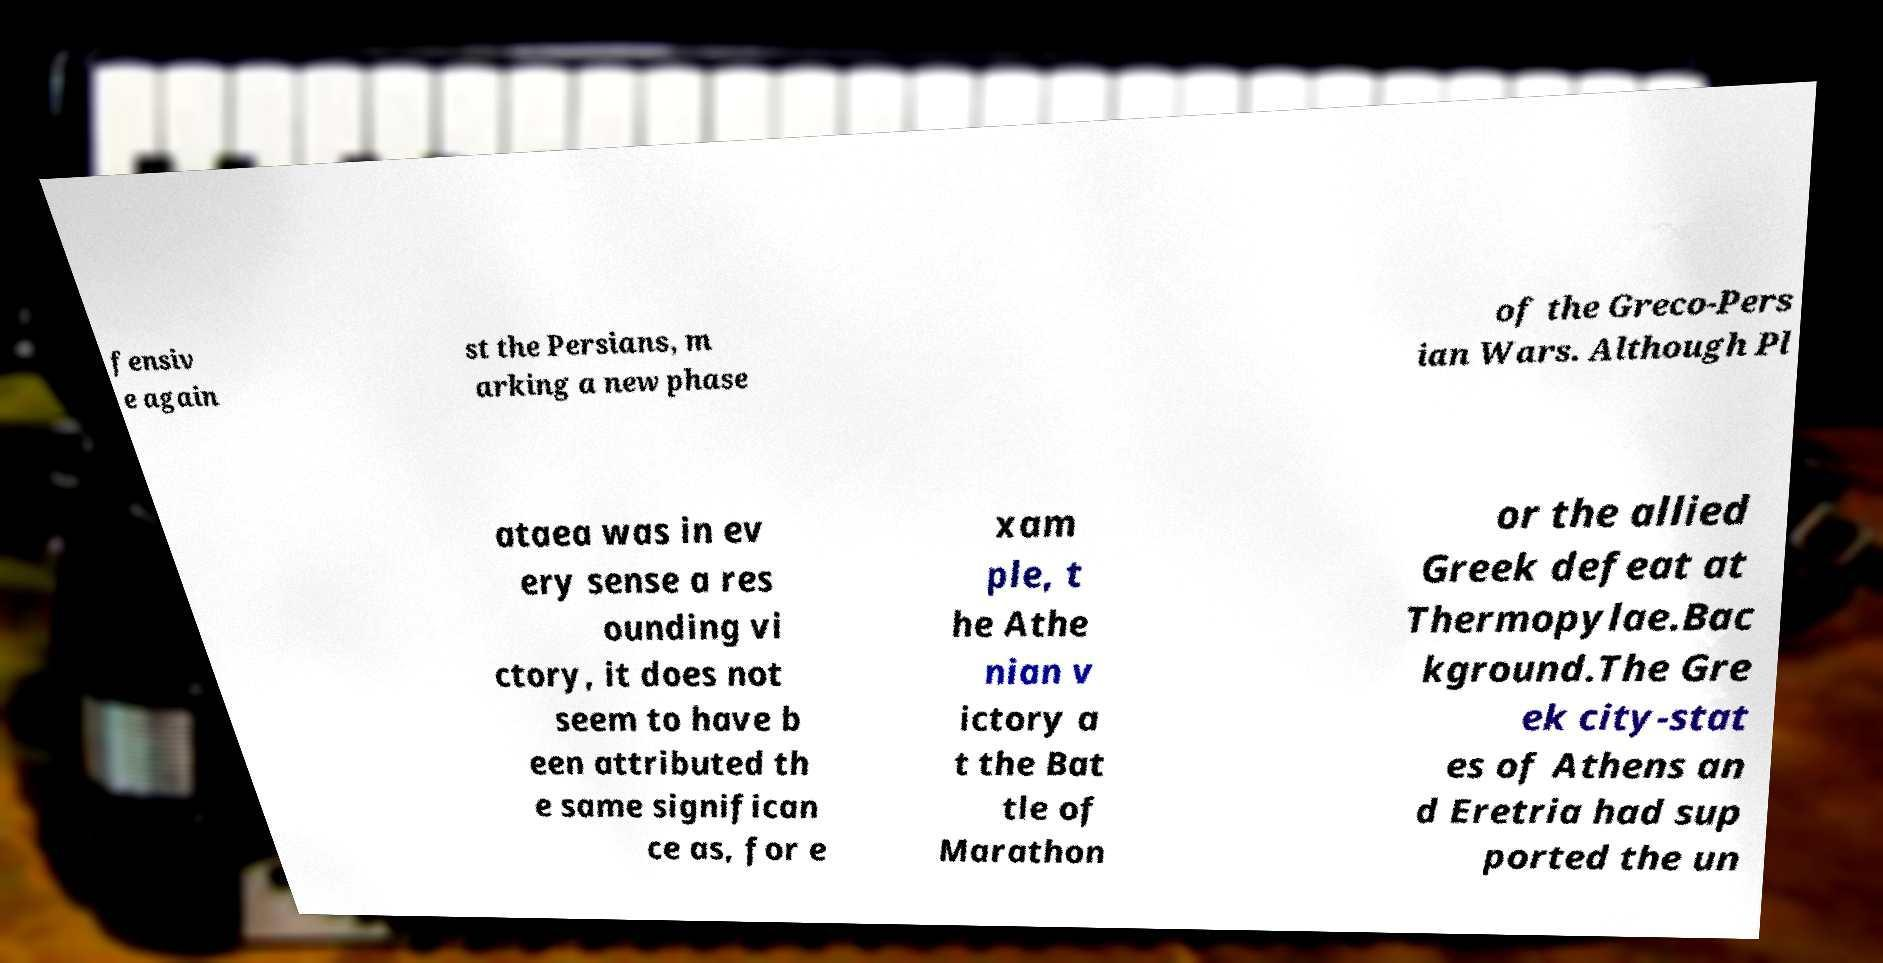There's text embedded in this image that I need extracted. Can you transcribe it verbatim? fensiv e again st the Persians, m arking a new phase of the Greco-Pers ian Wars. Although Pl ataea was in ev ery sense a res ounding vi ctory, it does not seem to have b een attributed th e same significan ce as, for e xam ple, t he Athe nian v ictory a t the Bat tle of Marathon or the allied Greek defeat at Thermopylae.Bac kground.The Gre ek city-stat es of Athens an d Eretria had sup ported the un 